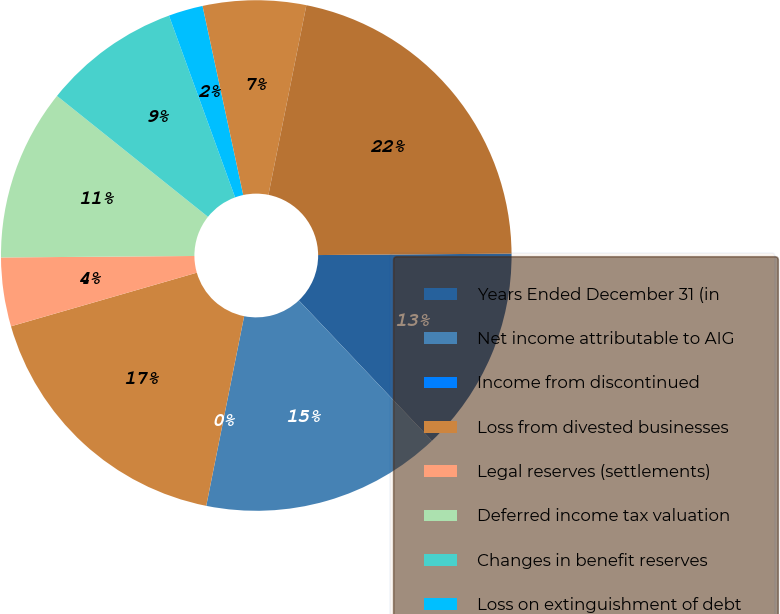Convert chart to OTSL. <chart><loc_0><loc_0><loc_500><loc_500><pie_chart><fcel>Years Ended December 31 (in<fcel>Net income attributable to AIG<fcel>Income from discontinued<fcel>Loss from divested businesses<fcel>Legal reserves (settlements)<fcel>Deferred income tax valuation<fcel>Changes in benefit reserves<fcel>Loss on extinguishment of debt<fcel>Net realized capital gains<fcel>After-tax operating income<nl><fcel>13.04%<fcel>15.22%<fcel>0.0%<fcel>17.39%<fcel>4.35%<fcel>10.87%<fcel>8.7%<fcel>2.18%<fcel>6.52%<fcel>21.74%<nl></chart> 